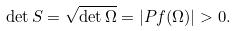Convert formula to latex. <formula><loc_0><loc_0><loc_500><loc_500>\det { S } = \sqrt { \det { \Omega } } = | P f ( { \Omega } ) | > 0 .</formula> 